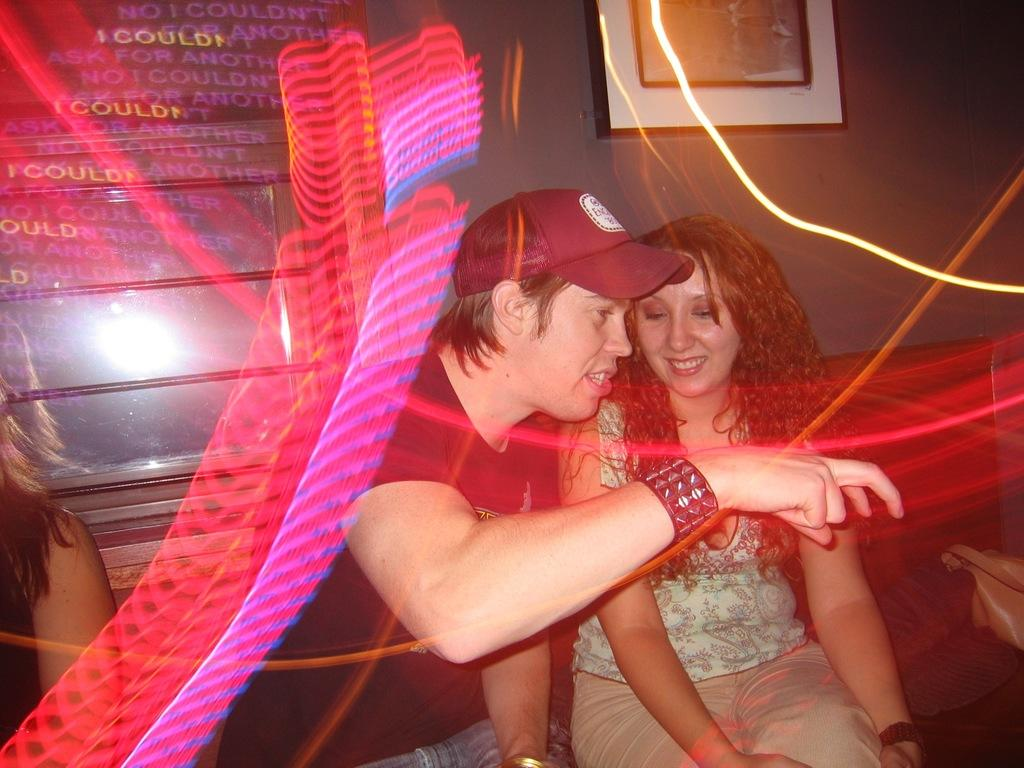What is happening in the room in the image? There are people sitting in the room. Can you describe any objects or belongings in the image? There is a handbag behind a person. What can be seen on the wall in the background? There is a wall with a photo frame in the background. What type of shoes are visible on the person sitting in the room? There are no shoes visible in the image; the focus is on the people sitting in the room and the handbag behind a person. 